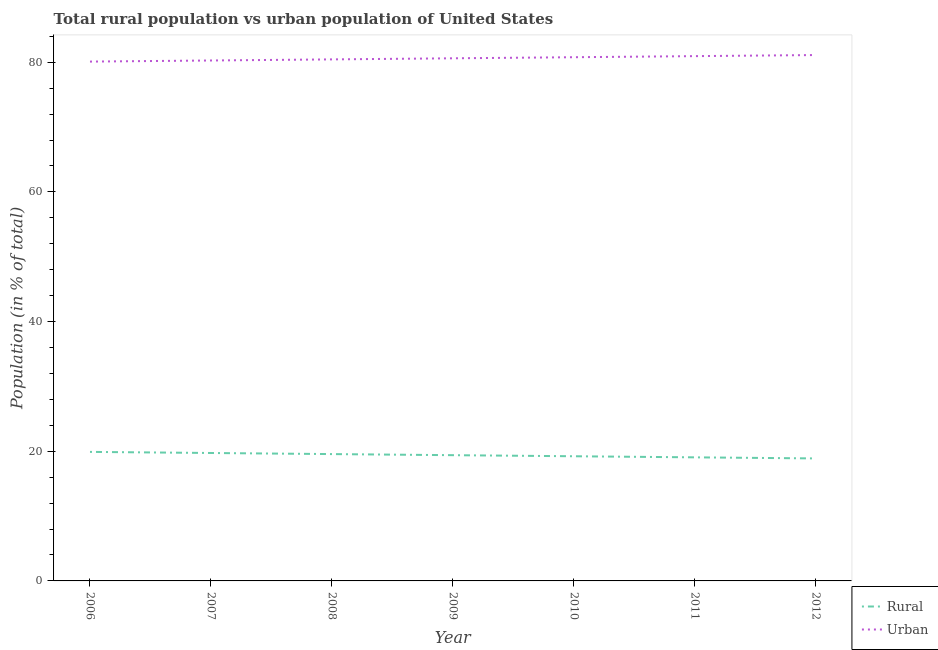How many different coloured lines are there?
Keep it short and to the point. 2. What is the rural population in 2010?
Make the answer very short. 19.23. Across all years, what is the maximum urban population?
Ensure brevity in your answer.  81.11. Across all years, what is the minimum rural population?
Provide a succinct answer. 18.89. In which year was the urban population maximum?
Give a very brief answer. 2012. In which year was the urban population minimum?
Keep it short and to the point. 2006. What is the total rural population in the graph?
Offer a very short reply. 135.77. What is the difference between the rural population in 2010 and that in 2011?
Give a very brief answer. 0.17. What is the difference between the rural population in 2010 and the urban population in 2009?
Make the answer very short. -61.38. What is the average urban population per year?
Keep it short and to the point. 80.6. In the year 2009, what is the difference between the urban population and rural population?
Ensure brevity in your answer.  61.21. In how many years, is the rural population greater than 48 %?
Give a very brief answer. 0. What is the ratio of the rural population in 2006 to that in 2007?
Your response must be concise. 1.01. What is the difference between the highest and the second highest urban population?
Your response must be concise. 0.17. What is the difference between the highest and the lowest urban population?
Provide a short and direct response. 1.01. In how many years, is the rural population greater than the average rural population taken over all years?
Offer a terse response. 3. Is the sum of the rural population in 2010 and 2012 greater than the maximum urban population across all years?
Offer a very short reply. No. Does the rural population monotonically increase over the years?
Offer a very short reply. No. Is the urban population strictly less than the rural population over the years?
Offer a very short reply. No. How many years are there in the graph?
Your response must be concise. 7. What is the difference between two consecutive major ticks on the Y-axis?
Make the answer very short. 20. Are the values on the major ticks of Y-axis written in scientific E-notation?
Your response must be concise. No. Does the graph contain any zero values?
Offer a very short reply. No. Does the graph contain grids?
Provide a succinct answer. No. Where does the legend appear in the graph?
Ensure brevity in your answer.  Bottom right. What is the title of the graph?
Your answer should be very brief. Total rural population vs urban population of United States. Does "Rural Population" appear as one of the legend labels in the graph?
Provide a short and direct response. No. What is the label or title of the Y-axis?
Offer a very short reply. Population (in % of total). What is the Population (in % of total) of Rural in 2006?
Your answer should be compact. 19.9. What is the Population (in % of total) of Urban in 2006?
Offer a very short reply. 80.1. What is the Population (in % of total) in Rural in 2007?
Ensure brevity in your answer.  19.73. What is the Population (in % of total) of Urban in 2007?
Ensure brevity in your answer.  80.27. What is the Population (in % of total) of Rural in 2008?
Provide a short and direct response. 19.56. What is the Population (in % of total) in Urban in 2008?
Your response must be concise. 80.44. What is the Population (in % of total) in Rural in 2009?
Give a very brief answer. 19.39. What is the Population (in % of total) of Urban in 2009?
Your answer should be very brief. 80.61. What is the Population (in % of total) of Rural in 2010?
Offer a terse response. 19.23. What is the Population (in % of total) in Urban in 2010?
Keep it short and to the point. 80.77. What is the Population (in % of total) in Rural in 2011?
Offer a very short reply. 19.06. What is the Population (in % of total) of Urban in 2011?
Keep it short and to the point. 80.94. What is the Population (in % of total) in Rural in 2012?
Provide a short and direct response. 18.89. What is the Population (in % of total) of Urban in 2012?
Give a very brief answer. 81.11. Across all years, what is the maximum Population (in % of total) in Rural?
Your response must be concise. 19.9. Across all years, what is the maximum Population (in % of total) of Urban?
Your answer should be compact. 81.11. Across all years, what is the minimum Population (in % of total) in Rural?
Your answer should be very brief. 18.89. Across all years, what is the minimum Population (in % of total) in Urban?
Provide a succinct answer. 80.1. What is the total Population (in % of total) of Rural in the graph?
Your answer should be compact. 135.77. What is the total Population (in % of total) in Urban in the graph?
Offer a terse response. 564.23. What is the difference between the Population (in % of total) of Rural in 2006 and that in 2007?
Offer a terse response. 0.17. What is the difference between the Population (in % of total) of Urban in 2006 and that in 2007?
Offer a terse response. -0.17. What is the difference between the Population (in % of total) in Rural in 2006 and that in 2008?
Make the answer very short. 0.34. What is the difference between the Population (in % of total) of Urban in 2006 and that in 2008?
Offer a terse response. -0.34. What is the difference between the Population (in % of total) of Rural in 2006 and that in 2009?
Ensure brevity in your answer.  0.51. What is the difference between the Population (in % of total) in Urban in 2006 and that in 2009?
Provide a short and direct response. -0.51. What is the difference between the Population (in % of total) in Rural in 2006 and that in 2010?
Your answer should be very brief. 0.67. What is the difference between the Population (in % of total) of Urban in 2006 and that in 2010?
Make the answer very short. -0.67. What is the difference between the Population (in % of total) of Rural in 2006 and that in 2011?
Your answer should be compact. 0.84. What is the difference between the Population (in % of total) in Urban in 2006 and that in 2011?
Provide a succinct answer. -0.84. What is the difference between the Population (in % of total) of Urban in 2006 and that in 2012?
Ensure brevity in your answer.  -1.01. What is the difference between the Population (in % of total) of Rural in 2007 and that in 2008?
Your answer should be compact. 0.17. What is the difference between the Population (in % of total) in Urban in 2007 and that in 2008?
Provide a short and direct response. -0.17. What is the difference between the Population (in % of total) of Rural in 2007 and that in 2009?
Your answer should be compact. 0.34. What is the difference between the Population (in % of total) of Urban in 2007 and that in 2009?
Make the answer very short. -0.34. What is the difference between the Population (in % of total) of Rural in 2007 and that in 2010?
Keep it short and to the point. 0.5. What is the difference between the Population (in % of total) of Urban in 2007 and that in 2010?
Your answer should be very brief. -0.5. What is the difference between the Population (in % of total) of Rural in 2007 and that in 2011?
Provide a short and direct response. 0.67. What is the difference between the Population (in % of total) in Urban in 2007 and that in 2011?
Your answer should be compact. -0.67. What is the difference between the Population (in % of total) in Rural in 2007 and that in 2012?
Give a very brief answer. 0.84. What is the difference between the Population (in % of total) in Urban in 2007 and that in 2012?
Keep it short and to the point. -0.84. What is the difference between the Population (in % of total) in Rural in 2008 and that in 2009?
Offer a terse response. 0.17. What is the difference between the Population (in % of total) of Urban in 2008 and that in 2009?
Provide a short and direct response. -0.17. What is the difference between the Population (in % of total) of Rural in 2008 and that in 2010?
Your answer should be compact. 0.33. What is the difference between the Population (in % of total) in Urban in 2008 and that in 2010?
Make the answer very short. -0.33. What is the difference between the Population (in % of total) in Rural in 2008 and that in 2011?
Offer a terse response. 0.5. What is the difference between the Population (in % of total) of Urban in 2008 and that in 2011?
Make the answer very short. -0.5. What is the difference between the Population (in % of total) of Rural in 2008 and that in 2012?
Provide a succinct answer. 0.67. What is the difference between the Population (in % of total) in Urban in 2008 and that in 2012?
Make the answer very short. -0.67. What is the difference between the Population (in % of total) of Rural in 2009 and that in 2010?
Ensure brevity in your answer.  0.17. What is the difference between the Population (in % of total) of Urban in 2009 and that in 2010?
Ensure brevity in your answer.  -0.17. What is the difference between the Population (in % of total) in Rural in 2009 and that in 2011?
Provide a succinct answer. 0.33. What is the difference between the Population (in % of total) in Urban in 2009 and that in 2011?
Offer a terse response. -0.33. What is the difference between the Population (in % of total) in Rural in 2009 and that in 2012?
Provide a succinct answer. 0.5. What is the difference between the Population (in % of total) in Urban in 2009 and that in 2012?
Offer a terse response. -0.5. What is the difference between the Population (in % of total) in Rural in 2010 and that in 2011?
Your answer should be very brief. 0.17. What is the difference between the Population (in % of total) of Urban in 2010 and that in 2011?
Your answer should be compact. -0.17. What is the difference between the Population (in % of total) of Rural in 2010 and that in 2012?
Give a very brief answer. 0.34. What is the difference between the Population (in % of total) in Urban in 2010 and that in 2012?
Provide a short and direct response. -0.34. What is the difference between the Population (in % of total) in Rural in 2011 and that in 2012?
Your response must be concise. 0.17. What is the difference between the Population (in % of total) in Urban in 2011 and that in 2012?
Your answer should be very brief. -0.17. What is the difference between the Population (in % of total) of Rural in 2006 and the Population (in % of total) of Urban in 2007?
Ensure brevity in your answer.  -60.37. What is the difference between the Population (in % of total) of Rural in 2006 and the Population (in % of total) of Urban in 2008?
Give a very brief answer. -60.54. What is the difference between the Population (in % of total) in Rural in 2006 and the Population (in % of total) in Urban in 2009?
Make the answer very short. -60.7. What is the difference between the Population (in % of total) in Rural in 2006 and the Population (in % of total) in Urban in 2010?
Give a very brief answer. -60.87. What is the difference between the Population (in % of total) of Rural in 2006 and the Population (in % of total) of Urban in 2011?
Your answer should be very brief. -61.04. What is the difference between the Population (in % of total) in Rural in 2006 and the Population (in % of total) in Urban in 2012?
Provide a short and direct response. -61.21. What is the difference between the Population (in % of total) in Rural in 2007 and the Population (in % of total) in Urban in 2008?
Provide a succinct answer. -60.71. What is the difference between the Population (in % of total) of Rural in 2007 and the Population (in % of total) of Urban in 2009?
Offer a very short reply. -60.88. What is the difference between the Population (in % of total) of Rural in 2007 and the Population (in % of total) of Urban in 2010?
Keep it short and to the point. -61.04. What is the difference between the Population (in % of total) in Rural in 2007 and the Population (in % of total) in Urban in 2011?
Your answer should be very brief. -61.21. What is the difference between the Population (in % of total) of Rural in 2007 and the Population (in % of total) of Urban in 2012?
Give a very brief answer. -61.38. What is the difference between the Population (in % of total) of Rural in 2008 and the Population (in % of total) of Urban in 2009?
Offer a terse response. -61.04. What is the difference between the Population (in % of total) of Rural in 2008 and the Population (in % of total) of Urban in 2010?
Make the answer very short. -61.21. What is the difference between the Population (in % of total) of Rural in 2008 and the Population (in % of total) of Urban in 2011?
Offer a terse response. -61.38. What is the difference between the Population (in % of total) in Rural in 2008 and the Population (in % of total) in Urban in 2012?
Ensure brevity in your answer.  -61.55. What is the difference between the Population (in % of total) of Rural in 2009 and the Population (in % of total) of Urban in 2010?
Your answer should be very brief. -61.38. What is the difference between the Population (in % of total) in Rural in 2009 and the Population (in % of total) in Urban in 2011?
Offer a terse response. -61.55. What is the difference between the Population (in % of total) in Rural in 2009 and the Population (in % of total) in Urban in 2012?
Provide a succinct answer. -61.71. What is the difference between the Population (in % of total) of Rural in 2010 and the Population (in % of total) of Urban in 2011?
Your answer should be very brief. -61.71. What is the difference between the Population (in % of total) in Rural in 2010 and the Population (in % of total) in Urban in 2012?
Provide a succinct answer. -61.88. What is the difference between the Population (in % of total) in Rural in 2011 and the Population (in % of total) in Urban in 2012?
Keep it short and to the point. -62.05. What is the average Population (in % of total) of Rural per year?
Make the answer very short. 19.4. What is the average Population (in % of total) in Urban per year?
Keep it short and to the point. 80.6. In the year 2006, what is the difference between the Population (in % of total) in Rural and Population (in % of total) in Urban?
Make the answer very short. -60.2. In the year 2007, what is the difference between the Population (in % of total) of Rural and Population (in % of total) of Urban?
Make the answer very short. -60.54. In the year 2008, what is the difference between the Population (in % of total) in Rural and Population (in % of total) in Urban?
Provide a short and direct response. -60.88. In the year 2009, what is the difference between the Population (in % of total) in Rural and Population (in % of total) in Urban?
Your answer should be very brief. -61.21. In the year 2010, what is the difference between the Population (in % of total) of Rural and Population (in % of total) of Urban?
Your answer should be very brief. -61.54. In the year 2011, what is the difference between the Population (in % of total) of Rural and Population (in % of total) of Urban?
Give a very brief answer. -61.88. In the year 2012, what is the difference between the Population (in % of total) of Rural and Population (in % of total) of Urban?
Provide a succinct answer. -62.22. What is the ratio of the Population (in % of total) of Rural in 2006 to that in 2007?
Your answer should be compact. 1.01. What is the ratio of the Population (in % of total) in Rural in 2006 to that in 2008?
Provide a succinct answer. 1.02. What is the ratio of the Population (in % of total) of Urban in 2006 to that in 2008?
Give a very brief answer. 1. What is the ratio of the Population (in % of total) in Rural in 2006 to that in 2009?
Make the answer very short. 1.03. What is the ratio of the Population (in % of total) of Urban in 2006 to that in 2009?
Your response must be concise. 0.99. What is the ratio of the Population (in % of total) in Rural in 2006 to that in 2010?
Keep it short and to the point. 1.03. What is the ratio of the Population (in % of total) in Urban in 2006 to that in 2010?
Make the answer very short. 0.99. What is the ratio of the Population (in % of total) of Rural in 2006 to that in 2011?
Your answer should be very brief. 1.04. What is the ratio of the Population (in % of total) of Rural in 2006 to that in 2012?
Keep it short and to the point. 1.05. What is the ratio of the Population (in % of total) of Urban in 2006 to that in 2012?
Provide a succinct answer. 0.99. What is the ratio of the Population (in % of total) of Rural in 2007 to that in 2008?
Your answer should be very brief. 1.01. What is the ratio of the Population (in % of total) of Urban in 2007 to that in 2008?
Offer a very short reply. 1. What is the ratio of the Population (in % of total) of Rural in 2007 to that in 2009?
Make the answer very short. 1.02. What is the ratio of the Population (in % of total) of Urban in 2007 to that in 2009?
Your response must be concise. 1. What is the ratio of the Population (in % of total) in Rural in 2007 to that in 2010?
Keep it short and to the point. 1.03. What is the ratio of the Population (in % of total) in Urban in 2007 to that in 2010?
Ensure brevity in your answer.  0.99. What is the ratio of the Population (in % of total) in Rural in 2007 to that in 2011?
Your answer should be very brief. 1.04. What is the ratio of the Population (in % of total) in Urban in 2007 to that in 2011?
Your answer should be compact. 0.99. What is the ratio of the Population (in % of total) in Rural in 2007 to that in 2012?
Your answer should be compact. 1.04. What is the ratio of the Population (in % of total) in Urban in 2007 to that in 2012?
Provide a short and direct response. 0.99. What is the ratio of the Population (in % of total) in Rural in 2008 to that in 2009?
Your answer should be compact. 1.01. What is the ratio of the Population (in % of total) in Urban in 2008 to that in 2009?
Keep it short and to the point. 1. What is the ratio of the Population (in % of total) of Rural in 2008 to that in 2010?
Give a very brief answer. 1.02. What is the ratio of the Population (in % of total) of Urban in 2008 to that in 2010?
Offer a very short reply. 1. What is the ratio of the Population (in % of total) in Rural in 2008 to that in 2011?
Make the answer very short. 1.03. What is the ratio of the Population (in % of total) in Rural in 2008 to that in 2012?
Your response must be concise. 1.04. What is the ratio of the Population (in % of total) in Urban in 2008 to that in 2012?
Offer a very short reply. 0.99. What is the ratio of the Population (in % of total) in Rural in 2009 to that in 2010?
Make the answer very short. 1.01. What is the ratio of the Population (in % of total) in Rural in 2009 to that in 2011?
Offer a very short reply. 1.02. What is the ratio of the Population (in % of total) in Rural in 2009 to that in 2012?
Your answer should be compact. 1.03. What is the ratio of the Population (in % of total) of Rural in 2010 to that in 2011?
Make the answer very short. 1.01. What is the ratio of the Population (in % of total) in Rural in 2010 to that in 2012?
Your answer should be very brief. 1.02. What is the ratio of the Population (in % of total) in Rural in 2011 to that in 2012?
Ensure brevity in your answer.  1.01. What is the ratio of the Population (in % of total) of Urban in 2011 to that in 2012?
Offer a very short reply. 1. What is the difference between the highest and the second highest Population (in % of total) in Rural?
Keep it short and to the point. 0.17. What is the difference between the highest and the second highest Population (in % of total) in Urban?
Your answer should be very brief. 0.17. What is the difference between the highest and the lowest Population (in % of total) of Rural?
Give a very brief answer. 1.01. What is the difference between the highest and the lowest Population (in % of total) in Urban?
Provide a short and direct response. 1.01. 